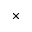<formula> <loc_0><loc_0><loc_500><loc_500>\times</formula> 